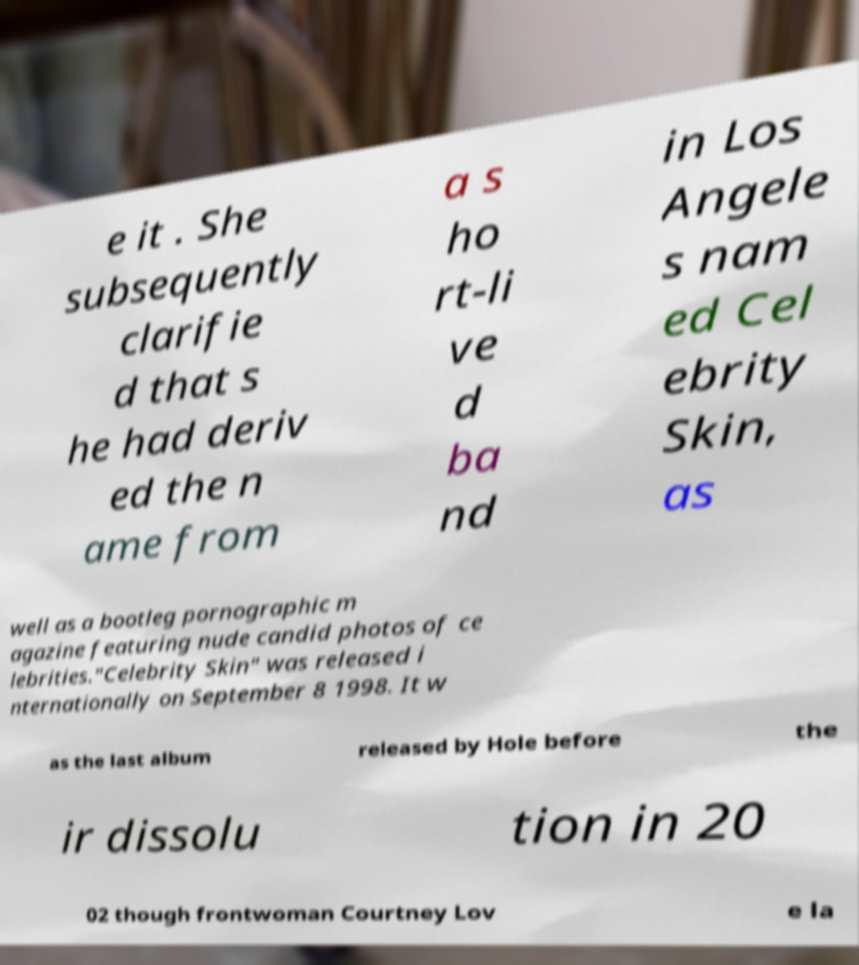What messages or text are displayed in this image? I need them in a readable, typed format. e it . She subsequently clarifie d that s he had deriv ed the n ame from a s ho rt-li ve d ba nd in Los Angele s nam ed Cel ebrity Skin, as well as a bootleg pornographic m agazine featuring nude candid photos of ce lebrities."Celebrity Skin" was released i nternationally on September 8 1998. It w as the last album released by Hole before the ir dissolu tion in 20 02 though frontwoman Courtney Lov e la 